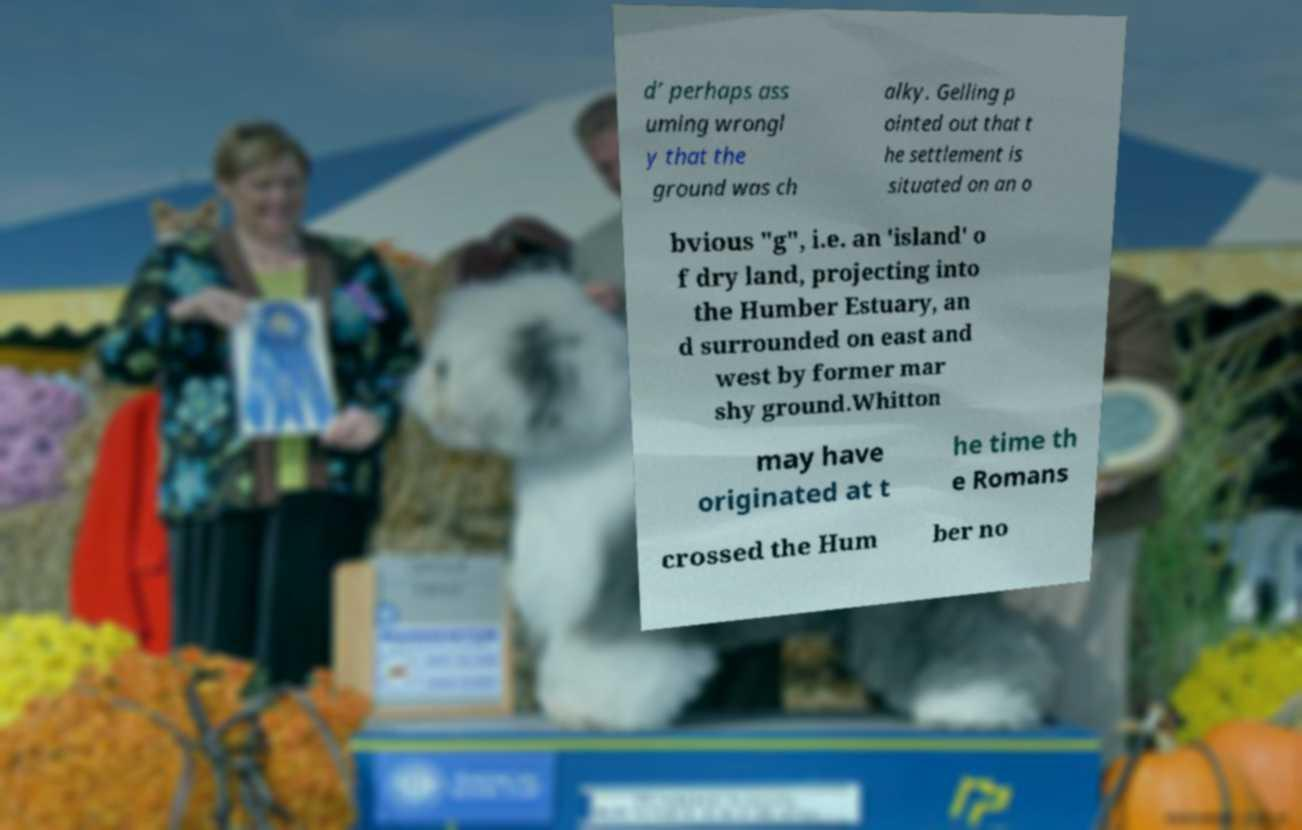Please read and relay the text visible in this image. What does it say? d’ perhaps ass uming wrongl y that the ground was ch alky. Gelling p ointed out that t he settlement is situated on an o bvious "g", i.e. an 'island' o f dry land, projecting into the Humber Estuary, an d surrounded on east and west by former mar shy ground.Whitton may have originated at t he time th e Romans crossed the Hum ber no 